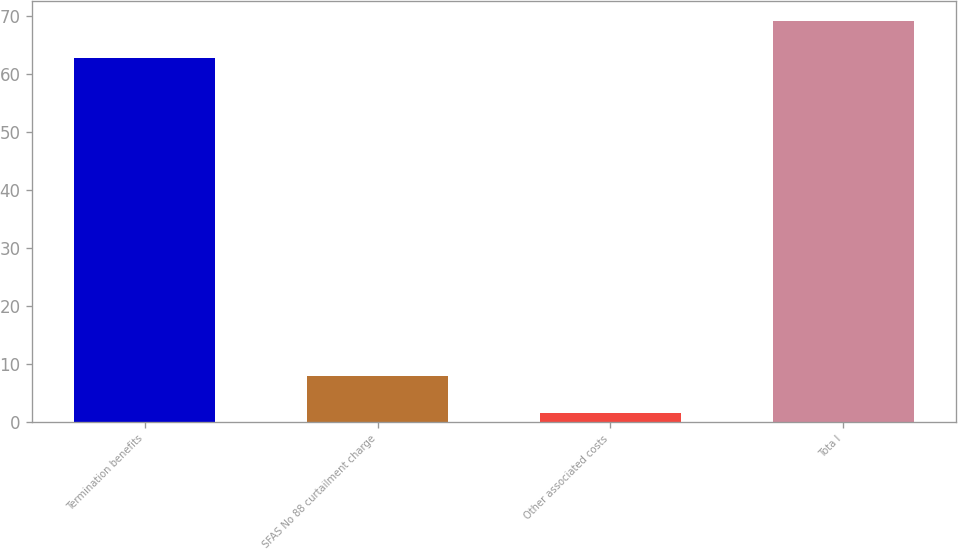<chart> <loc_0><loc_0><loc_500><loc_500><bar_chart><fcel>Termination benefits<fcel>SFAS No 88 curtailment charge<fcel>Other associated costs<fcel>Tota l<nl><fcel>62.7<fcel>7.93<fcel>1.5<fcel>69.13<nl></chart> 